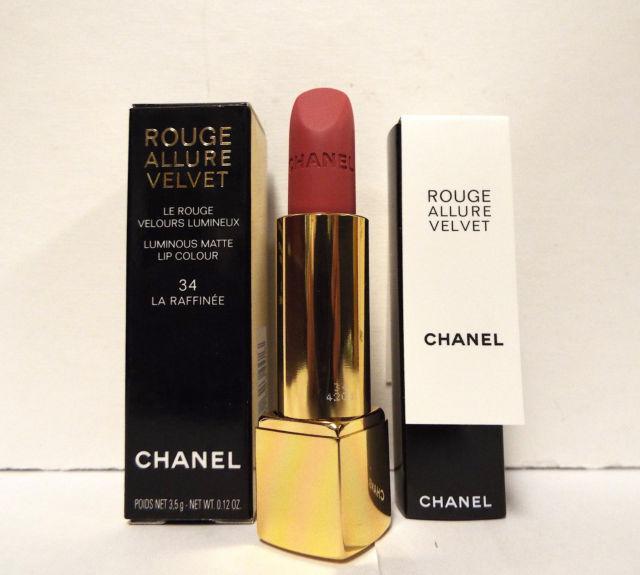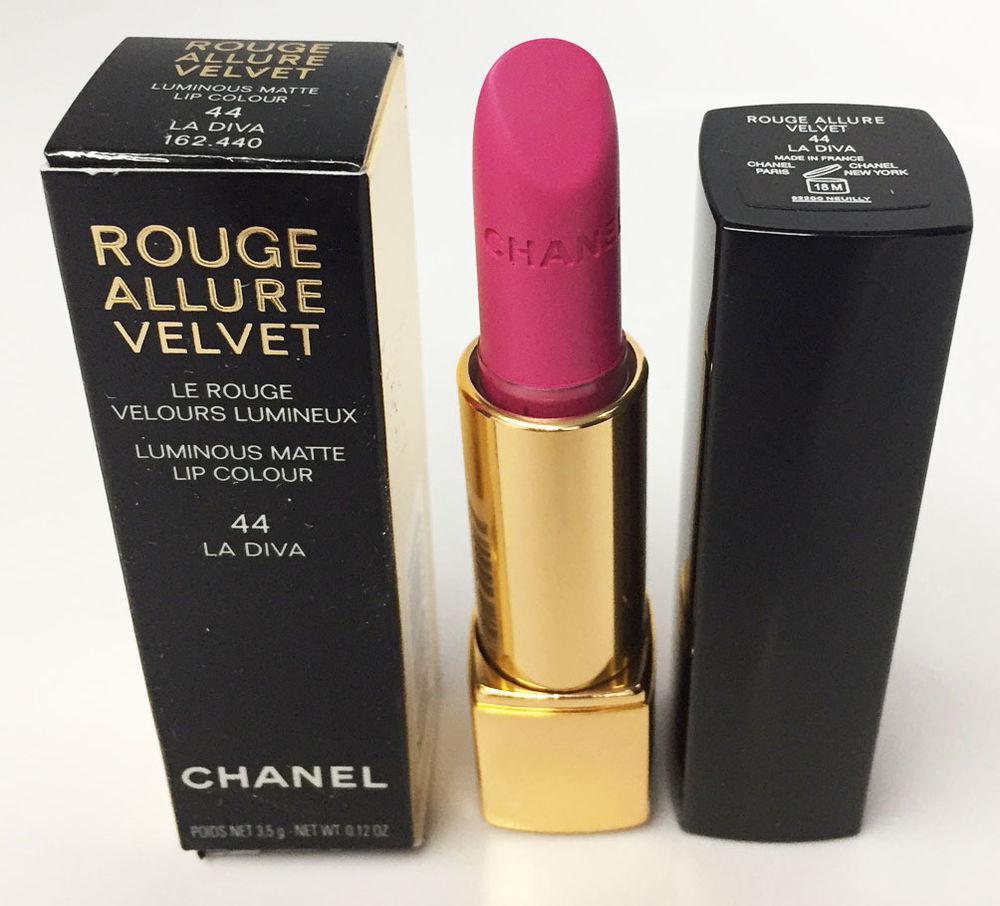The first image is the image on the left, the second image is the image on the right. Assess this claim about the two images: "There are no more than four lipsticks in the image on the left.". Correct or not? Answer yes or no. Yes. The first image is the image on the left, the second image is the image on the right. Examine the images to the left and right. Is the description "The left image shows at least four traditional lipsticks." accurate? Answer yes or no. No. 